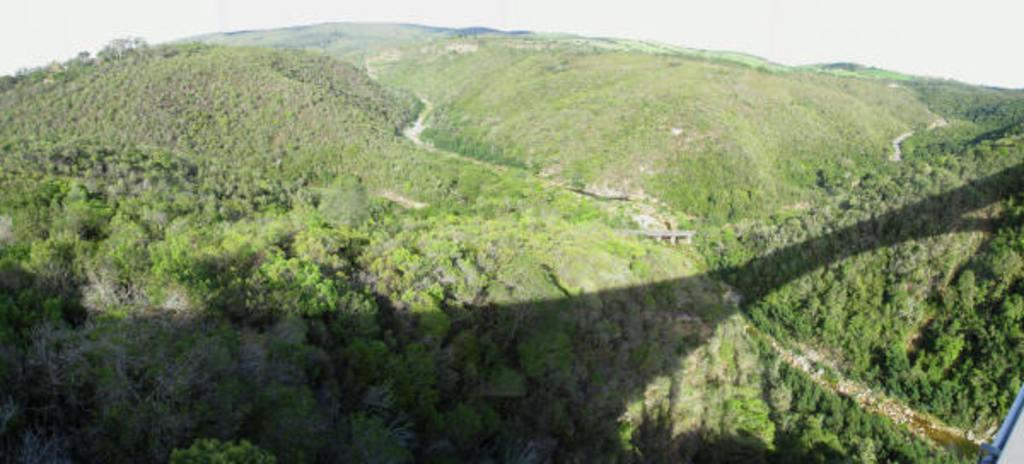What type of landscape is depicted in the image? The image features hills. What can be seen on the hills in the image? The hills are covered with trees. What advice does the duck in the image give to the viewers? There is no duck present in the image, so no advice can be given by a duck. 